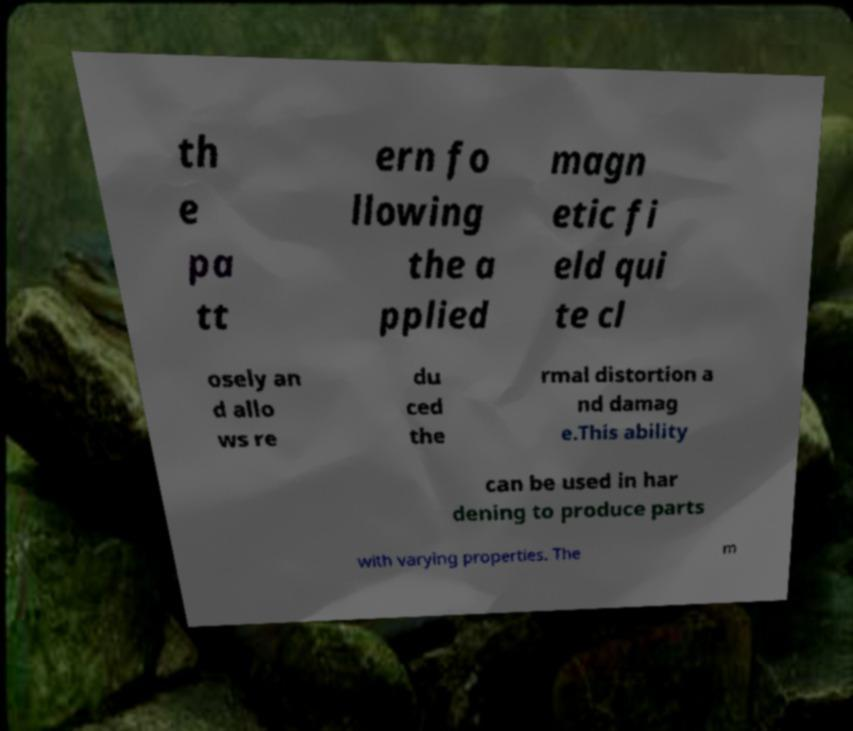I need the written content from this picture converted into text. Can you do that? th e pa tt ern fo llowing the a pplied magn etic fi eld qui te cl osely an d allo ws re du ced the rmal distortion a nd damag e.This ability can be used in har dening to produce parts with varying properties. The m 